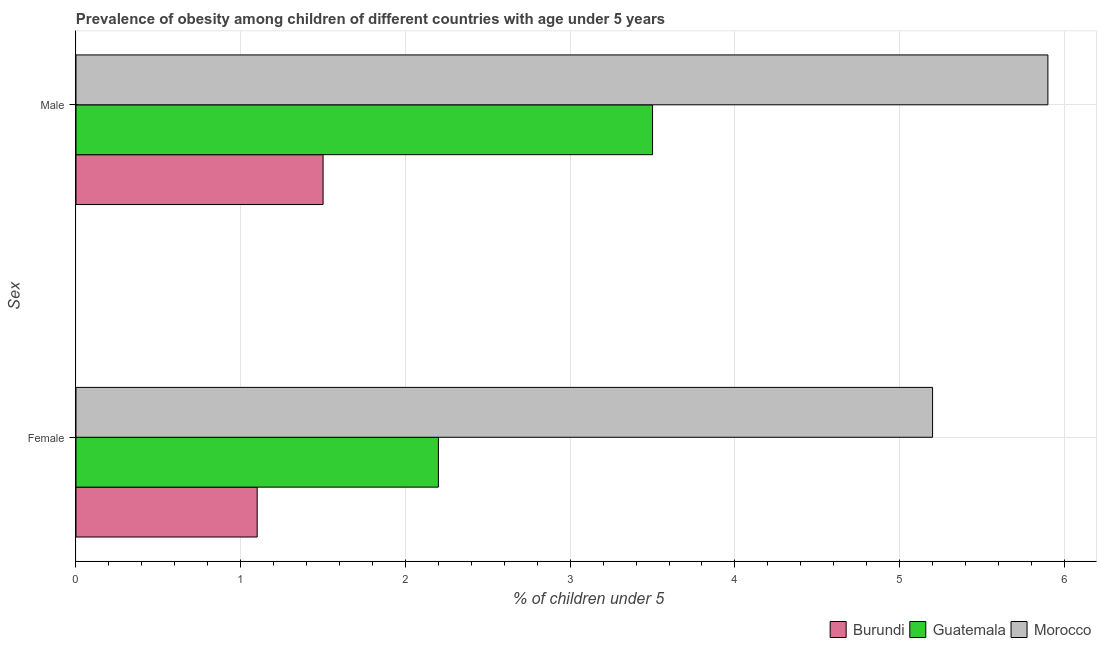How many different coloured bars are there?
Offer a terse response. 3. How many groups of bars are there?
Provide a succinct answer. 2. What is the label of the 2nd group of bars from the top?
Your answer should be compact. Female. Across all countries, what is the maximum percentage of obese female children?
Your answer should be very brief. 5.2. In which country was the percentage of obese male children maximum?
Offer a terse response. Morocco. In which country was the percentage of obese male children minimum?
Make the answer very short. Burundi. What is the total percentage of obese female children in the graph?
Make the answer very short. 8.5. What is the difference between the percentage of obese female children in Morocco and that in Burundi?
Your answer should be very brief. 4.1. What is the difference between the percentage of obese female children in Morocco and the percentage of obese male children in Burundi?
Keep it short and to the point. 3.7. What is the average percentage of obese female children per country?
Make the answer very short. 2.83. What is the difference between the percentage of obese male children and percentage of obese female children in Burundi?
Your answer should be very brief. 0.4. What is the ratio of the percentage of obese male children in Guatemala to that in Burundi?
Provide a short and direct response. 2.33. In how many countries, is the percentage of obese female children greater than the average percentage of obese female children taken over all countries?
Your response must be concise. 1. What does the 2nd bar from the top in Male represents?
Offer a terse response. Guatemala. What does the 2nd bar from the bottom in Male represents?
Offer a terse response. Guatemala. What is the difference between two consecutive major ticks on the X-axis?
Ensure brevity in your answer.  1. Does the graph contain grids?
Provide a short and direct response. Yes. How are the legend labels stacked?
Offer a terse response. Horizontal. What is the title of the graph?
Your response must be concise. Prevalence of obesity among children of different countries with age under 5 years. What is the label or title of the X-axis?
Provide a succinct answer.  % of children under 5. What is the label or title of the Y-axis?
Provide a short and direct response. Sex. What is the  % of children under 5 in Burundi in Female?
Ensure brevity in your answer.  1.1. What is the  % of children under 5 of Guatemala in Female?
Offer a terse response. 2.2. What is the  % of children under 5 of Morocco in Female?
Your answer should be compact. 5.2. What is the  % of children under 5 of Burundi in Male?
Offer a terse response. 1.5. What is the  % of children under 5 of Guatemala in Male?
Give a very brief answer. 3.5. What is the  % of children under 5 of Morocco in Male?
Your response must be concise. 5.9. Across all Sex, what is the maximum  % of children under 5 in Guatemala?
Provide a succinct answer. 3.5. Across all Sex, what is the maximum  % of children under 5 in Morocco?
Make the answer very short. 5.9. Across all Sex, what is the minimum  % of children under 5 in Burundi?
Offer a very short reply. 1.1. Across all Sex, what is the minimum  % of children under 5 of Guatemala?
Offer a terse response. 2.2. Across all Sex, what is the minimum  % of children under 5 in Morocco?
Your response must be concise. 5.2. What is the total  % of children under 5 in Burundi in the graph?
Offer a very short reply. 2.6. What is the total  % of children under 5 in Guatemala in the graph?
Give a very brief answer. 5.7. What is the total  % of children under 5 of Morocco in the graph?
Offer a terse response. 11.1. What is the difference between the  % of children under 5 of Burundi in Female and that in Male?
Keep it short and to the point. -0.4. What is the difference between the  % of children under 5 in Morocco in Female and that in Male?
Provide a short and direct response. -0.7. What is the difference between the  % of children under 5 in Burundi in Female and the  % of children under 5 in Guatemala in Male?
Your response must be concise. -2.4. What is the difference between the  % of children under 5 in Burundi in Female and the  % of children under 5 in Morocco in Male?
Make the answer very short. -4.8. What is the difference between the  % of children under 5 of Guatemala in Female and the  % of children under 5 of Morocco in Male?
Your answer should be very brief. -3.7. What is the average  % of children under 5 of Guatemala per Sex?
Your answer should be very brief. 2.85. What is the average  % of children under 5 in Morocco per Sex?
Offer a terse response. 5.55. What is the difference between the  % of children under 5 of Burundi and  % of children under 5 of Guatemala in Female?
Your answer should be compact. -1.1. What is the difference between the  % of children under 5 of Burundi and  % of children under 5 of Morocco in Female?
Give a very brief answer. -4.1. What is the ratio of the  % of children under 5 of Burundi in Female to that in Male?
Your answer should be very brief. 0.73. What is the ratio of the  % of children under 5 of Guatemala in Female to that in Male?
Your response must be concise. 0.63. What is the ratio of the  % of children under 5 of Morocco in Female to that in Male?
Your answer should be very brief. 0.88. What is the difference between the highest and the second highest  % of children under 5 in Burundi?
Your response must be concise. 0.4. What is the difference between the highest and the second highest  % of children under 5 of Guatemala?
Give a very brief answer. 1.3. What is the difference between the highest and the second highest  % of children under 5 in Morocco?
Make the answer very short. 0.7. What is the difference between the highest and the lowest  % of children under 5 in Burundi?
Your response must be concise. 0.4. What is the difference between the highest and the lowest  % of children under 5 of Guatemala?
Provide a succinct answer. 1.3. What is the difference between the highest and the lowest  % of children under 5 in Morocco?
Offer a very short reply. 0.7. 